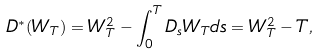Convert formula to latex. <formula><loc_0><loc_0><loc_500><loc_500>D ^ { * } ( W _ { T } ) = W _ { T } ^ { 2 } - \int _ { 0 } ^ { T } D _ { s } W _ { T } d s = W _ { T } ^ { 2 } - T ,</formula> 